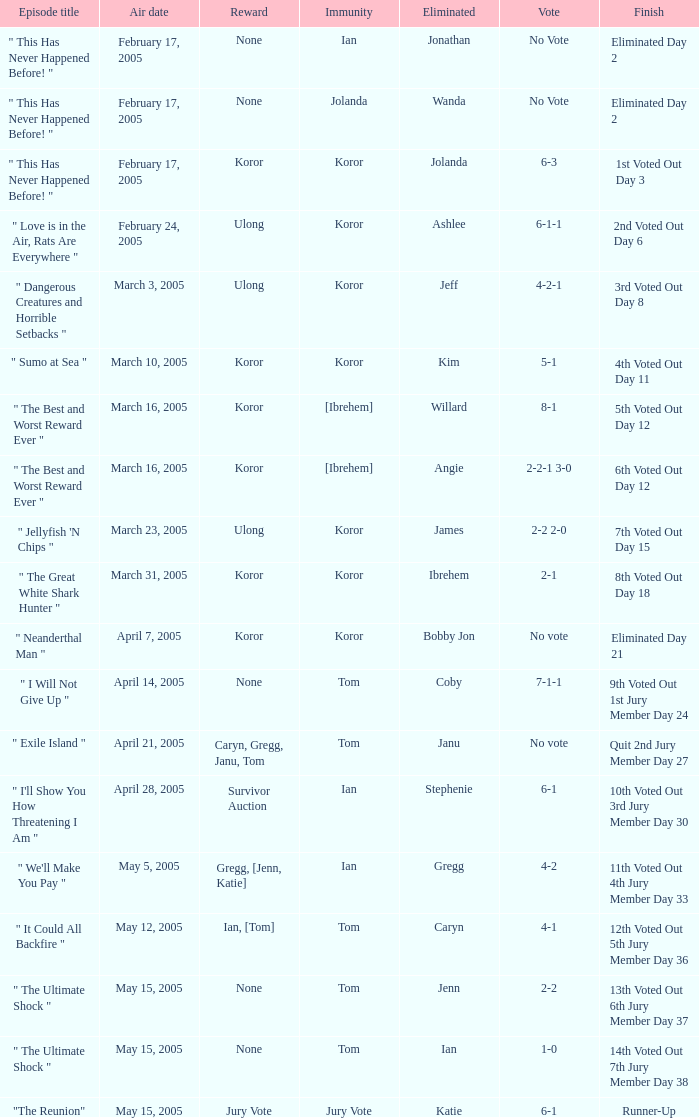What was the vote on the episode where the finish was "10th voted out 3rd jury member day 30"? 6-1. 